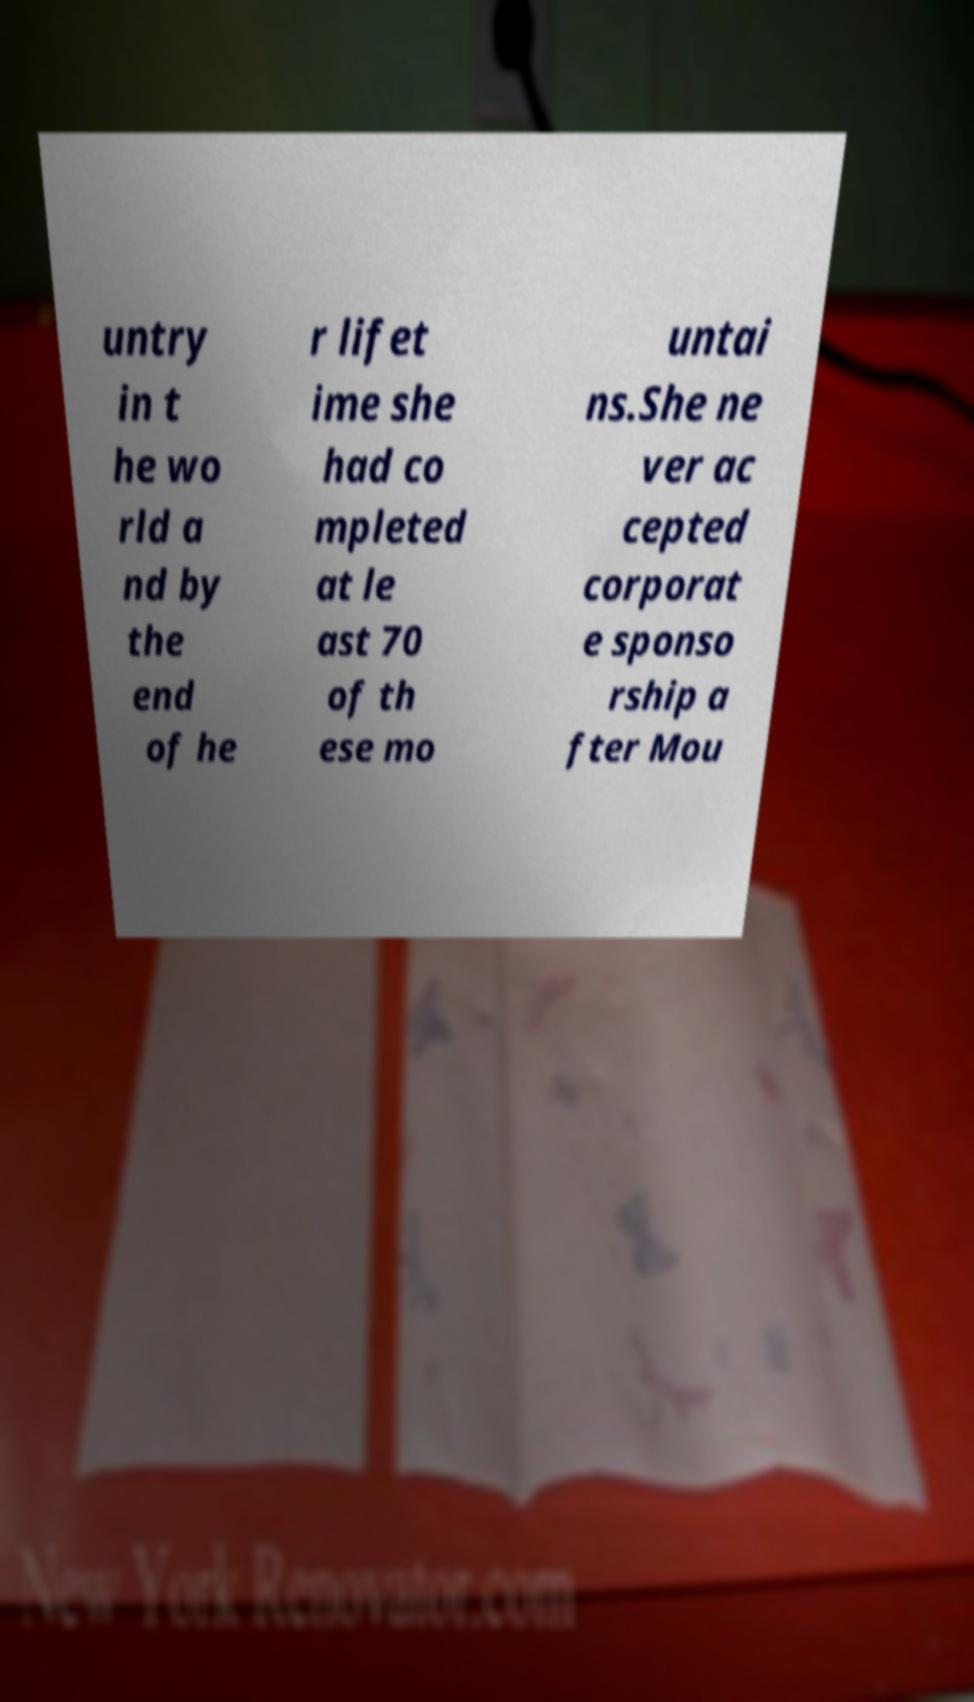I need the written content from this picture converted into text. Can you do that? untry in t he wo rld a nd by the end of he r lifet ime she had co mpleted at le ast 70 of th ese mo untai ns.She ne ver ac cepted corporat e sponso rship a fter Mou 